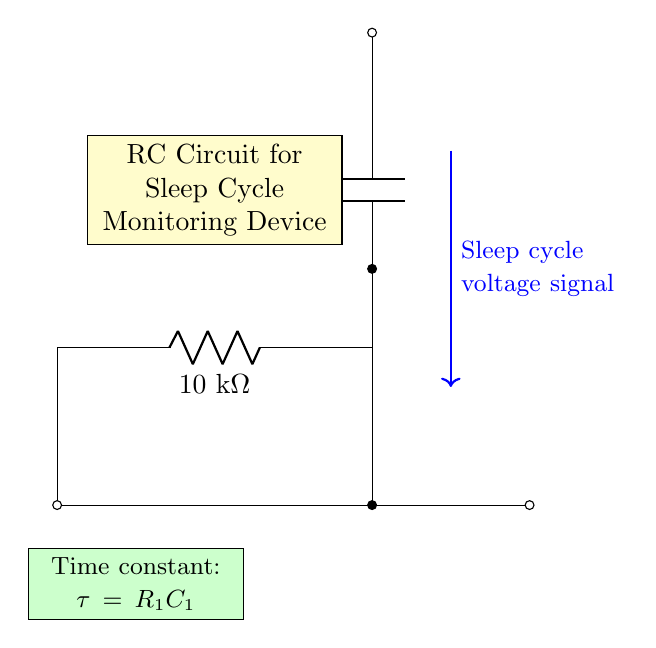What is the value of the resistor in this circuit? The resistor's value is indicated next to it in the circuit diagram. It shows R1 is labeled as 10 kΩ.
Answer: 10 kΩ What is the value of the capacitor in this circuit? The capacitor's value is provided in the circuit diagram. It is labeled as C1 with a value of 100 nF.
Answer: 100 nF What is the time constant of this circuit? The time constant τ for an RC circuit is calculated using the formula τ = R1 * C1. Here, R1 is 10 kΩ and C1 is 100 nF, so τ = 10 kΩ * 100 nF = 1 ms.
Answer: 1 ms What type of signal is represented in this circuit? The circuit includes a label indicating the type of signal at a specific point. It states that the signal is a "sleep cycle voltage signal."
Answer: Sleep cycle voltage signal How does an RC circuit affect the sleep cycle monitoring? The RC circuit can filter and smooth out the voltage signal received from sleep cycle data. The combination of resistor and capacitor allows for timing and processing of the signal, which is essential for monitoring changes in sleep cycles effectively.
Answer: It filters and smooths the signal What would happen if the resistance value were doubled? If the resistance is doubled, the time constant τ would also double since τ = R1 * C1, meaning the circuit would respond more slowly to changes in the voltage signal. This could potentially delay the monitoring response to sleep cycle changes.
Answer: The monitoring response would slow down Where are the input and output terminals located? The input terminal is indicated with a short line connected to the voltage source on the left side of the diagram, and the output terminal is at the right side where there is a short line leading out, signifying where the monitored signal exits the circuit.
Answer: Left for input, right for output 